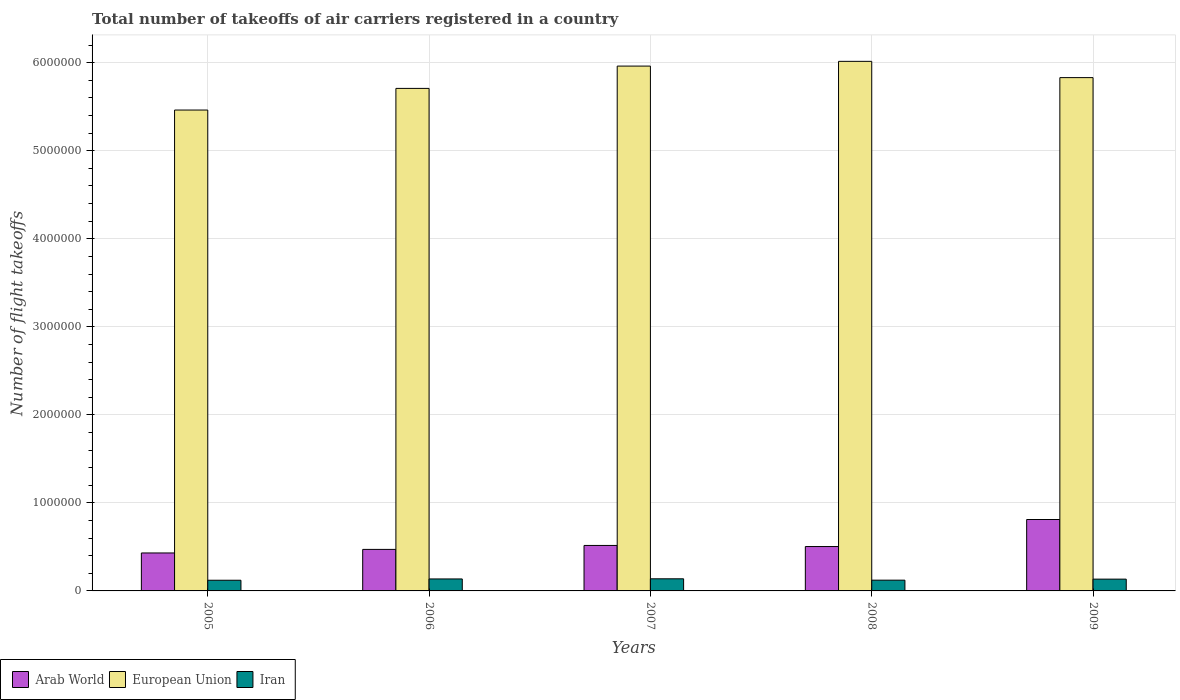Are the number of bars on each tick of the X-axis equal?
Offer a very short reply. Yes. How many bars are there on the 4th tick from the left?
Offer a very short reply. 3. How many bars are there on the 5th tick from the right?
Provide a succinct answer. 3. What is the label of the 2nd group of bars from the left?
Your answer should be very brief. 2006. In how many cases, is the number of bars for a given year not equal to the number of legend labels?
Your answer should be compact. 0. What is the total number of flight takeoffs in Arab World in 2008?
Your response must be concise. 5.04e+05. Across all years, what is the maximum total number of flight takeoffs in Arab World?
Provide a short and direct response. 8.11e+05. Across all years, what is the minimum total number of flight takeoffs in Iran?
Your answer should be compact. 1.21e+05. In which year was the total number of flight takeoffs in Iran minimum?
Your response must be concise. 2005. What is the total total number of flight takeoffs in European Union in the graph?
Provide a short and direct response. 2.90e+07. What is the difference between the total number of flight takeoffs in Iran in 2005 and that in 2009?
Ensure brevity in your answer.  -1.27e+04. What is the difference between the total number of flight takeoffs in Arab World in 2008 and the total number of flight takeoffs in Iran in 2006?
Offer a terse response. 3.68e+05. What is the average total number of flight takeoffs in European Union per year?
Make the answer very short. 5.80e+06. In the year 2007, what is the difference between the total number of flight takeoffs in Iran and total number of flight takeoffs in European Union?
Your answer should be compact. -5.82e+06. In how many years, is the total number of flight takeoffs in European Union greater than 2600000?
Offer a very short reply. 5. What is the ratio of the total number of flight takeoffs in European Union in 2007 to that in 2009?
Keep it short and to the point. 1.02. Is the total number of flight takeoffs in Iran in 2007 less than that in 2008?
Provide a short and direct response. No. Is the difference between the total number of flight takeoffs in Iran in 2007 and 2009 greater than the difference between the total number of flight takeoffs in European Union in 2007 and 2009?
Your answer should be very brief. No. What is the difference between the highest and the second highest total number of flight takeoffs in Iran?
Make the answer very short. 1570. What is the difference between the highest and the lowest total number of flight takeoffs in Iran?
Give a very brief answer. 1.64e+04. Is the sum of the total number of flight takeoffs in European Union in 2005 and 2008 greater than the maximum total number of flight takeoffs in Arab World across all years?
Ensure brevity in your answer.  Yes. What does the 2nd bar from the left in 2009 represents?
Provide a short and direct response. European Union. What does the 3rd bar from the right in 2005 represents?
Make the answer very short. Arab World. Is it the case that in every year, the sum of the total number of flight takeoffs in Iran and total number of flight takeoffs in Arab World is greater than the total number of flight takeoffs in European Union?
Make the answer very short. No. How many bars are there?
Your response must be concise. 15. Are all the bars in the graph horizontal?
Provide a succinct answer. No. What is the difference between two consecutive major ticks on the Y-axis?
Ensure brevity in your answer.  1.00e+06. Does the graph contain any zero values?
Keep it short and to the point. No. Does the graph contain grids?
Your answer should be compact. Yes. What is the title of the graph?
Keep it short and to the point. Total number of takeoffs of air carriers registered in a country. What is the label or title of the X-axis?
Give a very brief answer. Years. What is the label or title of the Y-axis?
Your response must be concise. Number of flight takeoffs. What is the Number of flight takeoffs in Arab World in 2005?
Your answer should be very brief. 4.31e+05. What is the Number of flight takeoffs in European Union in 2005?
Give a very brief answer. 5.46e+06. What is the Number of flight takeoffs of Iran in 2005?
Provide a succinct answer. 1.21e+05. What is the Number of flight takeoffs in Arab World in 2006?
Your answer should be very brief. 4.72e+05. What is the Number of flight takeoffs in European Union in 2006?
Give a very brief answer. 5.71e+06. What is the Number of flight takeoffs of Iran in 2006?
Provide a succinct answer. 1.36e+05. What is the Number of flight takeoffs in Arab World in 2007?
Your answer should be very brief. 5.17e+05. What is the Number of flight takeoffs of European Union in 2007?
Provide a short and direct response. 5.96e+06. What is the Number of flight takeoffs of Iran in 2007?
Keep it short and to the point. 1.38e+05. What is the Number of flight takeoffs of Arab World in 2008?
Provide a short and direct response. 5.04e+05. What is the Number of flight takeoffs of European Union in 2008?
Give a very brief answer. 6.02e+06. What is the Number of flight takeoffs of Iran in 2008?
Offer a very short reply. 1.22e+05. What is the Number of flight takeoffs of Arab World in 2009?
Offer a terse response. 8.11e+05. What is the Number of flight takeoffs of European Union in 2009?
Give a very brief answer. 5.83e+06. What is the Number of flight takeoffs in Iran in 2009?
Keep it short and to the point. 1.34e+05. Across all years, what is the maximum Number of flight takeoffs in Arab World?
Your answer should be very brief. 8.11e+05. Across all years, what is the maximum Number of flight takeoffs of European Union?
Your response must be concise. 6.02e+06. Across all years, what is the maximum Number of flight takeoffs of Iran?
Provide a succinct answer. 1.38e+05. Across all years, what is the minimum Number of flight takeoffs in Arab World?
Provide a succinct answer. 4.31e+05. Across all years, what is the minimum Number of flight takeoffs in European Union?
Ensure brevity in your answer.  5.46e+06. Across all years, what is the minimum Number of flight takeoffs of Iran?
Give a very brief answer. 1.21e+05. What is the total Number of flight takeoffs of Arab World in the graph?
Offer a very short reply. 2.74e+06. What is the total Number of flight takeoffs of European Union in the graph?
Ensure brevity in your answer.  2.90e+07. What is the total Number of flight takeoffs in Iran in the graph?
Ensure brevity in your answer.  6.51e+05. What is the difference between the Number of flight takeoffs of Arab World in 2005 and that in 2006?
Provide a short and direct response. -4.04e+04. What is the difference between the Number of flight takeoffs of European Union in 2005 and that in 2006?
Ensure brevity in your answer.  -2.46e+05. What is the difference between the Number of flight takeoffs in Iran in 2005 and that in 2006?
Offer a terse response. -1.48e+04. What is the difference between the Number of flight takeoffs of Arab World in 2005 and that in 2007?
Your answer should be compact. -8.54e+04. What is the difference between the Number of flight takeoffs in European Union in 2005 and that in 2007?
Keep it short and to the point. -4.99e+05. What is the difference between the Number of flight takeoffs in Iran in 2005 and that in 2007?
Offer a terse response. -1.64e+04. What is the difference between the Number of flight takeoffs of Arab World in 2005 and that in 2008?
Your answer should be compact. -7.29e+04. What is the difference between the Number of flight takeoffs in European Union in 2005 and that in 2008?
Your response must be concise. -5.53e+05. What is the difference between the Number of flight takeoffs in Iran in 2005 and that in 2008?
Provide a succinct answer. -991. What is the difference between the Number of flight takeoffs in Arab World in 2005 and that in 2009?
Provide a short and direct response. -3.80e+05. What is the difference between the Number of flight takeoffs in European Union in 2005 and that in 2009?
Provide a succinct answer. -3.68e+05. What is the difference between the Number of flight takeoffs in Iran in 2005 and that in 2009?
Offer a very short reply. -1.27e+04. What is the difference between the Number of flight takeoffs in Arab World in 2006 and that in 2007?
Offer a very short reply. -4.50e+04. What is the difference between the Number of flight takeoffs of European Union in 2006 and that in 2007?
Provide a succinct answer. -2.54e+05. What is the difference between the Number of flight takeoffs of Iran in 2006 and that in 2007?
Your answer should be compact. -1570. What is the difference between the Number of flight takeoffs in Arab World in 2006 and that in 2008?
Your answer should be very brief. -3.25e+04. What is the difference between the Number of flight takeoffs in European Union in 2006 and that in 2008?
Your answer should be very brief. -3.07e+05. What is the difference between the Number of flight takeoffs of Iran in 2006 and that in 2008?
Offer a very short reply. 1.38e+04. What is the difference between the Number of flight takeoffs of Arab World in 2006 and that in 2009?
Your answer should be compact. -3.40e+05. What is the difference between the Number of flight takeoffs of European Union in 2006 and that in 2009?
Keep it short and to the point. -1.22e+05. What is the difference between the Number of flight takeoffs in Iran in 2006 and that in 2009?
Offer a very short reply. 2143. What is the difference between the Number of flight takeoffs of Arab World in 2007 and that in 2008?
Provide a short and direct response. 1.25e+04. What is the difference between the Number of flight takeoffs in European Union in 2007 and that in 2008?
Offer a terse response. -5.37e+04. What is the difference between the Number of flight takeoffs of Iran in 2007 and that in 2008?
Provide a succinct answer. 1.54e+04. What is the difference between the Number of flight takeoffs of Arab World in 2007 and that in 2009?
Offer a very short reply. -2.95e+05. What is the difference between the Number of flight takeoffs in European Union in 2007 and that in 2009?
Offer a terse response. 1.31e+05. What is the difference between the Number of flight takeoffs in Iran in 2007 and that in 2009?
Your answer should be compact. 3713. What is the difference between the Number of flight takeoffs in Arab World in 2008 and that in 2009?
Provide a succinct answer. -3.07e+05. What is the difference between the Number of flight takeoffs of European Union in 2008 and that in 2009?
Make the answer very short. 1.85e+05. What is the difference between the Number of flight takeoffs in Iran in 2008 and that in 2009?
Your answer should be compact. -1.17e+04. What is the difference between the Number of flight takeoffs of Arab World in 2005 and the Number of flight takeoffs of European Union in 2006?
Keep it short and to the point. -5.28e+06. What is the difference between the Number of flight takeoffs of Arab World in 2005 and the Number of flight takeoffs of Iran in 2006?
Provide a succinct answer. 2.95e+05. What is the difference between the Number of flight takeoffs of European Union in 2005 and the Number of flight takeoffs of Iran in 2006?
Provide a short and direct response. 5.33e+06. What is the difference between the Number of flight takeoffs of Arab World in 2005 and the Number of flight takeoffs of European Union in 2007?
Your response must be concise. -5.53e+06. What is the difference between the Number of flight takeoffs in Arab World in 2005 and the Number of flight takeoffs in Iran in 2007?
Your response must be concise. 2.94e+05. What is the difference between the Number of flight takeoffs of European Union in 2005 and the Number of flight takeoffs of Iran in 2007?
Keep it short and to the point. 5.33e+06. What is the difference between the Number of flight takeoffs of Arab World in 2005 and the Number of flight takeoffs of European Union in 2008?
Ensure brevity in your answer.  -5.58e+06. What is the difference between the Number of flight takeoffs in Arab World in 2005 and the Number of flight takeoffs in Iran in 2008?
Keep it short and to the point. 3.09e+05. What is the difference between the Number of flight takeoffs in European Union in 2005 and the Number of flight takeoffs in Iran in 2008?
Keep it short and to the point. 5.34e+06. What is the difference between the Number of flight takeoffs in Arab World in 2005 and the Number of flight takeoffs in European Union in 2009?
Offer a very short reply. -5.40e+06. What is the difference between the Number of flight takeoffs of Arab World in 2005 and the Number of flight takeoffs of Iran in 2009?
Your answer should be compact. 2.97e+05. What is the difference between the Number of flight takeoffs of European Union in 2005 and the Number of flight takeoffs of Iran in 2009?
Ensure brevity in your answer.  5.33e+06. What is the difference between the Number of flight takeoffs in Arab World in 2006 and the Number of flight takeoffs in European Union in 2007?
Give a very brief answer. -5.49e+06. What is the difference between the Number of flight takeoffs of Arab World in 2006 and the Number of flight takeoffs of Iran in 2007?
Keep it short and to the point. 3.34e+05. What is the difference between the Number of flight takeoffs of European Union in 2006 and the Number of flight takeoffs of Iran in 2007?
Provide a short and direct response. 5.57e+06. What is the difference between the Number of flight takeoffs of Arab World in 2006 and the Number of flight takeoffs of European Union in 2008?
Make the answer very short. -5.54e+06. What is the difference between the Number of flight takeoffs of Arab World in 2006 and the Number of flight takeoffs of Iran in 2008?
Offer a terse response. 3.49e+05. What is the difference between the Number of flight takeoffs in European Union in 2006 and the Number of flight takeoffs in Iran in 2008?
Your answer should be very brief. 5.59e+06. What is the difference between the Number of flight takeoffs of Arab World in 2006 and the Number of flight takeoffs of European Union in 2009?
Your answer should be very brief. -5.36e+06. What is the difference between the Number of flight takeoffs of Arab World in 2006 and the Number of flight takeoffs of Iran in 2009?
Your response must be concise. 3.38e+05. What is the difference between the Number of flight takeoffs of European Union in 2006 and the Number of flight takeoffs of Iran in 2009?
Provide a short and direct response. 5.57e+06. What is the difference between the Number of flight takeoffs of Arab World in 2007 and the Number of flight takeoffs of European Union in 2008?
Provide a succinct answer. -5.50e+06. What is the difference between the Number of flight takeoffs of Arab World in 2007 and the Number of flight takeoffs of Iran in 2008?
Offer a very short reply. 3.94e+05. What is the difference between the Number of flight takeoffs of European Union in 2007 and the Number of flight takeoffs of Iran in 2008?
Your response must be concise. 5.84e+06. What is the difference between the Number of flight takeoffs of Arab World in 2007 and the Number of flight takeoffs of European Union in 2009?
Your answer should be compact. -5.31e+06. What is the difference between the Number of flight takeoffs in Arab World in 2007 and the Number of flight takeoffs in Iran in 2009?
Offer a terse response. 3.83e+05. What is the difference between the Number of flight takeoffs in European Union in 2007 and the Number of flight takeoffs in Iran in 2009?
Provide a succinct answer. 5.83e+06. What is the difference between the Number of flight takeoffs in Arab World in 2008 and the Number of flight takeoffs in European Union in 2009?
Offer a very short reply. -5.33e+06. What is the difference between the Number of flight takeoffs in Arab World in 2008 and the Number of flight takeoffs in Iran in 2009?
Give a very brief answer. 3.70e+05. What is the difference between the Number of flight takeoffs in European Union in 2008 and the Number of flight takeoffs in Iran in 2009?
Keep it short and to the point. 5.88e+06. What is the average Number of flight takeoffs of Arab World per year?
Provide a short and direct response. 5.47e+05. What is the average Number of flight takeoffs in European Union per year?
Offer a very short reply. 5.80e+06. What is the average Number of flight takeoffs of Iran per year?
Offer a terse response. 1.30e+05. In the year 2005, what is the difference between the Number of flight takeoffs in Arab World and Number of flight takeoffs in European Union?
Your answer should be compact. -5.03e+06. In the year 2005, what is the difference between the Number of flight takeoffs of Arab World and Number of flight takeoffs of Iran?
Make the answer very short. 3.10e+05. In the year 2005, what is the difference between the Number of flight takeoffs in European Union and Number of flight takeoffs in Iran?
Your answer should be compact. 5.34e+06. In the year 2006, what is the difference between the Number of flight takeoffs in Arab World and Number of flight takeoffs in European Union?
Keep it short and to the point. -5.24e+06. In the year 2006, what is the difference between the Number of flight takeoffs in Arab World and Number of flight takeoffs in Iran?
Provide a short and direct response. 3.36e+05. In the year 2006, what is the difference between the Number of flight takeoffs of European Union and Number of flight takeoffs of Iran?
Your response must be concise. 5.57e+06. In the year 2007, what is the difference between the Number of flight takeoffs in Arab World and Number of flight takeoffs in European Union?
Your response must be concise. -5.45e+06. In the year 2007, what is the difference between the Number of flight takeoffs in Arab World and Number of flight takeoffs in Iran?
Offer a terse response. 3.79e+05. In the year 2007, what is the difference between the Number of flight takeoffs of European Union and Number of flight takeoffs of Iran?
Make the answer very short. 5.82e+06. In the year 2008, what is the difference between the Number of flight takeoffs of Arab World and Number of flight takeoffs of European Union?
Offer a very short reply. -5.51e+06. In the year 2008, what is the difference between the Number of flight takeoffs of Arab World and Number of flight takeoffs of Iran?
Your response must be concise. 3.82e+05. In the year 2008, what is the difference between the Number of flight takeoffs of European Union and Number of flight takeoffs of Iran?
Offer a terse response. 5.89e+06. In the year 2009, what is the difference between the Number of flight takeoffs of Arab World and Number of flight takeoffs of European Union?
Provide a succinct answer. -5.02e+06. In the year 2009, what is the difference between the Number of flight takeoffs of Arab World and Number of flight takeoffs of Iran?
Your answer should be very brief. 6.77e+05. In the year 2009, what is the difference between the Number of flight takeoffs in European Union and Number of flight takeoffs in Iran?
Your answer should be very brief. 5.70e+06. What is the ratio of the Number of flight takeoffs of Arab World in 2005 to that in 2006?
Make the answer very short. 0.91. What is the ratio of the Number of flight takeoffs of European Union in 2005 to that in 2006?
Provide a succinct answer. 0.96. What is the ratio of the Number of flight takeoffs in Iran in 2005 to that in 2006?
Offer a very short reply. 0.89. What is the ratio of the Number of flight takeoffs in Arab World in 2005 to that in 2007?
Provide a succinct answer. 0.83. What is the ratio of the Number of flight takeoffs of European Union in 2005 to that in 2007?
Provide a succinct answer. 0.92. What is the ratio of the Number of flight takeoffs of Iran in 2005 to that in 2007?
Give a very brief answer. 0.88. What is the ratio of the Number of flight takeoffs of Arab World in 2005 to that in 2008?
Your answer should be compact. 0.86. What is the ratio of the Number of flight takeoffs in European Union in 2005 to that in 2008?
Provide a short and direct response. 0.91. What is the ratio of the Number of flight takeoffs of Arab World in 2005 to that in 2009?
Offer a terse response. 0.53. What is the ratio of the Number of flight takeoffs in European Union in 2005 to that in 2009?
Keep it short and to the point. 0.94. What is the ratio of the Number of flight takeoffs of Iran in 2005 to that in 2009?
Your response must be concise. 0.91. What is the ratio of the Number of flight takeoffs in European Union in 2006 to that in 2007?
Ensure brevity in your answer.  0.96. What is the ratio of the Number of flight takeoffs in Arab World in 2006 to that in 2008?
Provide a short and direct response. 0.94. What is the ratio of the Number of flight takeoffs in European Union in 2006 to that in 2008?
Provide a succinct answer. 0.95. What is the ratio of the Number of flight takeoffs of Iran in 2006 to that in 2008?
Ensure brevity in your answer.  1.11. What is the ratio of the Number of flight takeoffs in Arab World in 2006 to that in 2009?
Offer a terse response. 0.58. What is the ratio of the Number of flight takeoffs of Arab World in 2007 to that in 2008?
Keep it short and to the point. 1.02. What is the ratio of the Number of flight takeoffs of European Union in 2007 to that in 2008?
Offer a very short reply. 0.99. What is the ratio of the Number of flight takeoffs in Iran in 2007 to that in 2008?
Offer a terse response. 1.13. What is the ratio of the Number of flight takeoffs of Arab World in 2007 to that in 2009?
Provide a short and direct response. 0.64. What is the ratio of the Number of flight takeoffs of European Union in 2007 to that in 2009?
Your answer should be very brief. 1.02. What is the ratio of the Number of flight takeoffs in Iran in 2007 to that in 2009?
Your answer should be compact. 1.03. What is the ratio of the Number of flight takeoffs in Arab World in 2008 to that in 2009?
Your answer should be compact. 0.62. What is the ratio of the Number of flight takeoffs of European Union in 2008 to that in 2009?
Give a very brief answer. 1.03. What is the ratio of the Number of flight takeoffs of Iran in 2008 to that in 2009?
Your answer should be very brief. 0.91. What is the difference between the highest and the second highest Number of flight takeoffs in Arab World?
Your answer should be compact. 2.95e+05. What is the difference between the highest and the second highest Number of flight takeoffs of European Union?
Offer a terse response. 5.37e+04. What is the difference between the highest and the second highest Number of flight takeoffs in Iran?
Your answer should be compact. 1570. What is the difference between the highest and the lowest Number of flight takeoffs of Arab World?
Ensure brevity in your answer.  3.80e+05. What is the difference between the highest and the lowest Number of flight takeoffs in European Union?
Your answer should be very brief. 5.53e+05. What is the difference between the highest and the lowest Number of flight takeoffs in Iran?
Offer a terse response. 1.64e+04. 